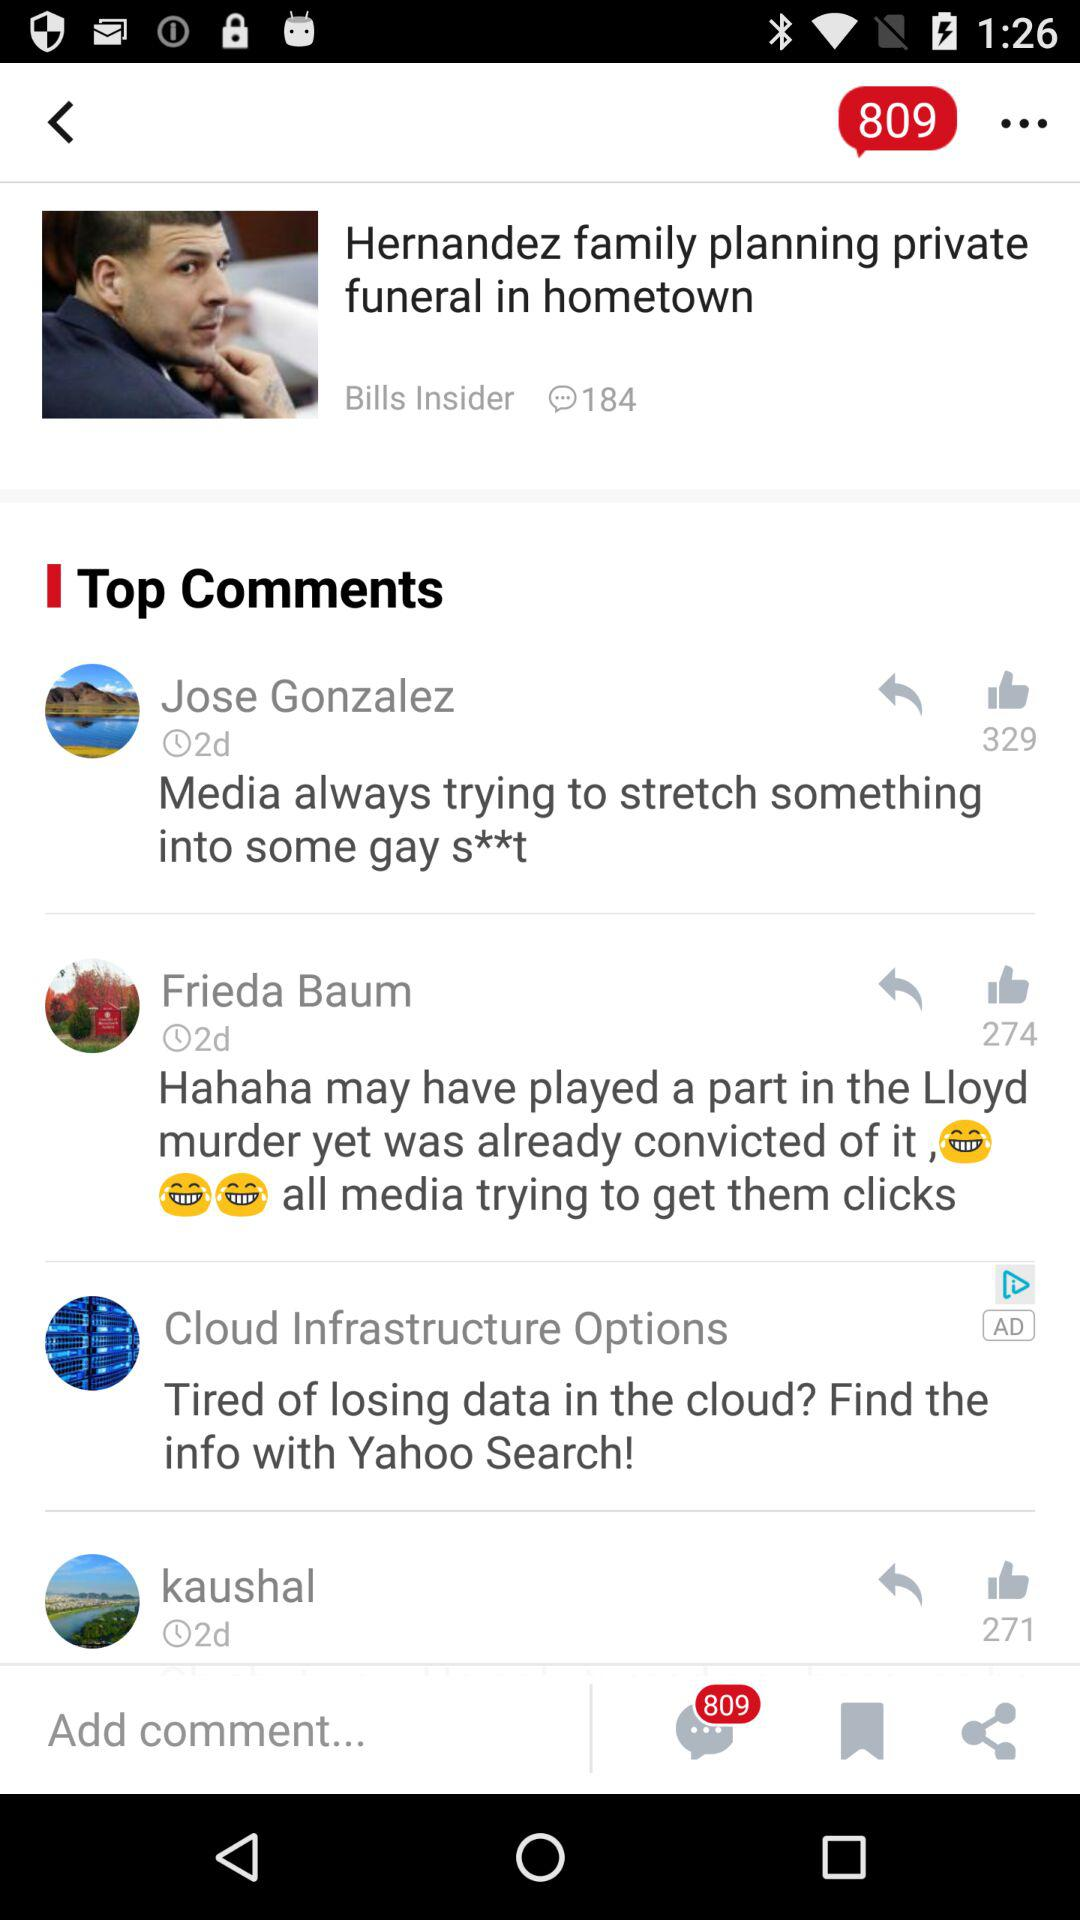How many likes are there of Kaushal's comment? There are 271 likes of Kaushal's comment. 